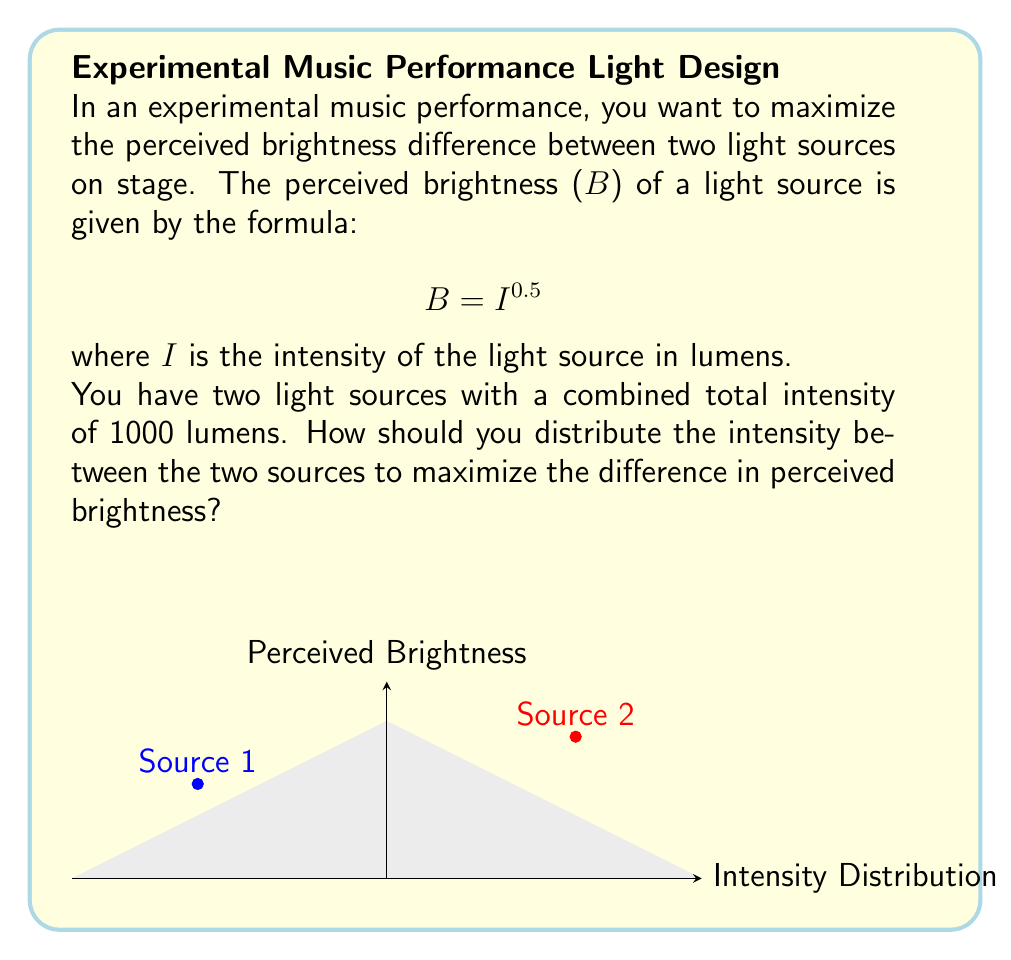Solve this math problem. Let's approach this step-by-step:

1) Let $x$ be the intensity of the first light source and $(1000-x)$ be the intensity of the second light source.

2) The perceived brightnesses are:
   $B_1 = x^{0.5}$ and $B_2 = (1000-x)^{0.5}$

3) We want to maximize the difference between these brightnesses:
   $f(x) = |(1000-x)^{0.5} - x^{0.5}|$

4) To find the maximum, we can differentiate $f(x)$ and set it to zero:
   $f'(x) = -\frac{1}{2}(1000-x)^{-0.5} - \frac{1}{2}x^{-0.5} = 0$

5) Solving this equation:
   $(1000-x)^{-0.5} = x^{-0.5}$
   $1000-x = x$
   $1000 = 2x$
   $x = 500$

6) This critical point gives us the maximum difference in perceived brightness.

7) The intensities should be distributed as 500 lumens for each source.

8) The perceived brightnesses will be:
   $B_1 = 500^{0.5} \approx 22.36$
   $B_2 = 500^{0.5} \approx 22.36$

9) Any other distribution would result in a smaller difference between the perceived brightnesses.
Answer: 500 lumens for each light source 